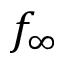<formula> <loc_0><loc_0><loc_500><loc_500>f _ { \infty }</formula> 